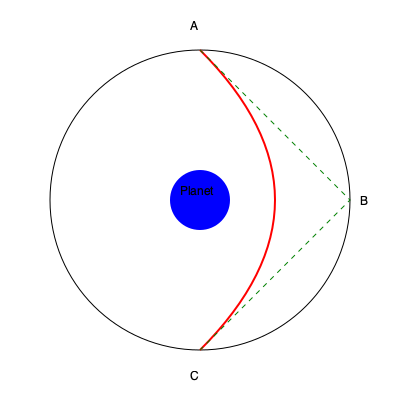A spacecraft is planned to perform a gravitational assist maneuver around a massive planet. The spacecraft's trajectory is represented by the red curve ABC in the diagram, while the green dashed line represents the straight-line path. Given that the planet's radius is 60,000 km and the closest approach distance is 30,000 km from the planet's center, calculate the deflection angle θ of the spacecraft's trajectory. Assume the spacecraft's speed at infinity is 20 km/s and the planet's mass is $6 \times 10^{26}$ kg. To solve this problem, we'll use the formula for the deflection angle in a hyperbolic orbit:

1) The deflection angle θ is given by:
   $$\theta = 2 \arcsin(\frac{1}{e})$$
   where e is the eccentricity of the hyperbolic orbit.

2) To find e, we need to calculate the impact parameter b:
   $$b = r_p \sqrt{1 + \frac{2GM}{r_pv_\infty^2}}$$
   where $r_p$ is the closest approach distance, G is the gravitational constant, M is the planet's mass, and $v_\infty$ is the spacecraft's speed at infinity.

3) Calculate GM:
   $$GM = 6.674 \times 10^{-11} \times 6 \times 10^{26} = 4.0044 \times 10^{16} \text{ m}^3/\text{s}^2$$

4) Calculate b:
   $$b = 30,000,000 \sqrt{1 + \frac{2 \times 4.0044 \times 10^{16}}{30,000,000 \times (20,000)^2}} = 41,569,219 \text{ m}$$

5) Now calculate the eccentricity e:
   $$e = \sqrt{1 + (\frac{bv_\infty^2}{GM})^2} = \sqrt{1 + (\frac{41,569,219 \times 20,000^2}{4.0044 \times 10^{16}})^2} = 1.3858$$

6) Finally, calculate the deflection angle θ:
   $$\theta = 2 \arcsin(\frac{1}{1.3858}) = 1.8675 \text{ radians}$$

7) Convert to degrees:
   $$\theta = 1.8675 \times \frac{180}{\pi} = 107.0°$$
Answer: 107.0° 